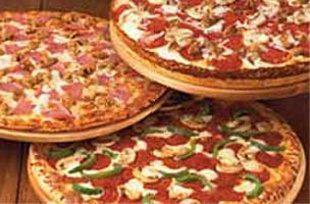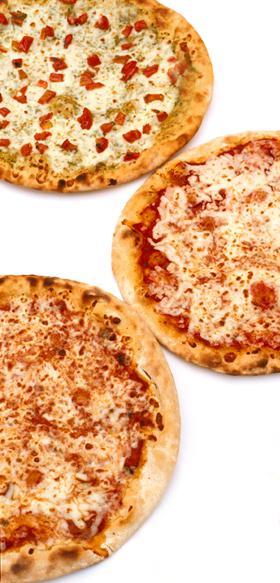The first image is the image on the left, the second image is the image on the right. For the images displayed, is the sentence "At least one pizza has been sliced." factually correct? Answer yes or no. No. The first image is the image on the left, the second image is the image on the right. For the images shown, is this caption "There are three uncut pizzas, two are to left at the same hight and a single pizza is on the right side." true? Answer yes or no. No. 